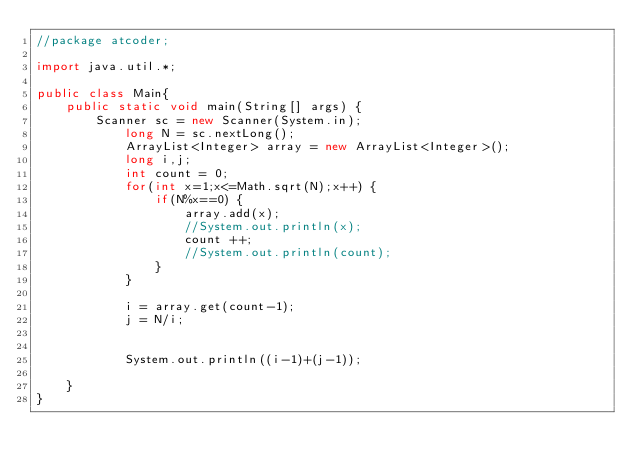<code> <loc_0><loc_0><loc_500><loc_500><_Java_>//package atcoder;

import java.util.*;

public class Main{
	public static void main(String[] args) {
		Scanner sc = new Scanner(System.in);
			long N = sc.nextLong();
			ArrayList<Integer> array = new ArrayList<Integer>();
	        long i,j;
	        int count = 0;
			for(int x=1;x<=Math.sqrt(N);x++) {
				if(N%x==0) {
					array.add(x);
					//System.out.println(x);
					count ++;	
					//System.out.println(count);
		        }
         	}
			
			i = array.get(count-1);
			j = N/i;
			
			
			System.out.println((i-1)+(j-1));

	}
}</code> 